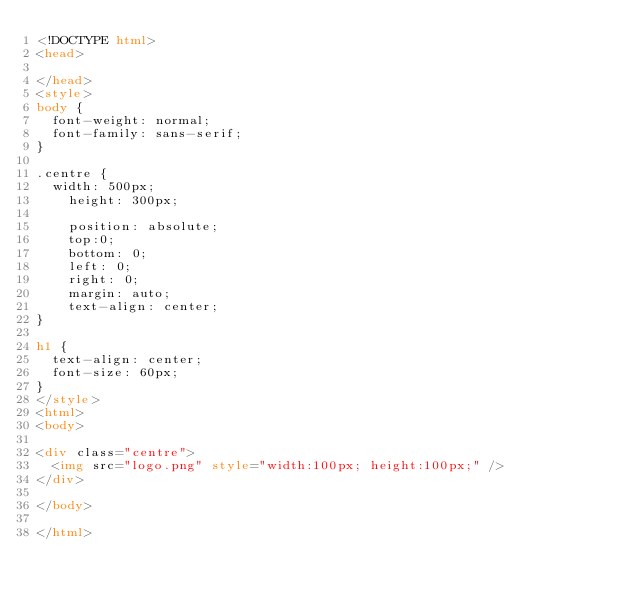Convert code to text. <code><loc_0><loc_0><loc_500><loc_500><_HTML_><!DOCTYPE html>
<head>

</head>
<style>
body {
  font-weight: normal;
  font-family: sans-serif;
}

.centre {
  width: 500px;
    height: 300px;

    position: absolute;
    top:0;
    bottom: 0;
    left: 0;
    right: 0;
    margin: auto;
    text-align: center;
}

h1 {
  text-align: center;
  font-size: 60px;
}
</style>
<html>
<body>

<div class="centre">
  <img src="logo.png" style="width:100px; height:100px;" />
</div>

</body>

</html>
</code> 